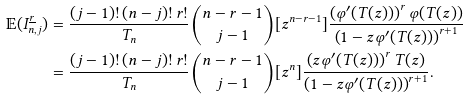<formula> <loc_0><loc_0><loc_500><loc_500>\mathbb { E } ( I _ { n , j } ^ { \underline { r } } ) & = \frac { ( j - 1 ) ! \, ( n - j ) ! \, r ! } { T _ { n } } \binom { n - r - 1 } { j - 1 } [ z ^ { n - r - 1 } ] \frac { \left ( \varphi ^ { \prime } ( T ( z ) ) \right ) ^ { r } \varphi ( T ( z ) ) } { \left ( 1 - z \varphi ^ { \prime } ( T ( z ) ) \right ) ^ { r + 1 } } \\ & = \frac { ( j - 1 ) ! \, ( n - j ) ! \, r ! } { T _ { n } } \binom { n - r - 1 } { j - 1 } [ z ^ { n } ] \frac { \left ( z \varphi ^ { \prime } ( T ( z ) ) \right ) ^ { r } T ( z ) } { \left ( 1 - z \varphi ^ { \prime } ( T ( z ) ) \right ) ^ { r + 1 } } .</formula> 